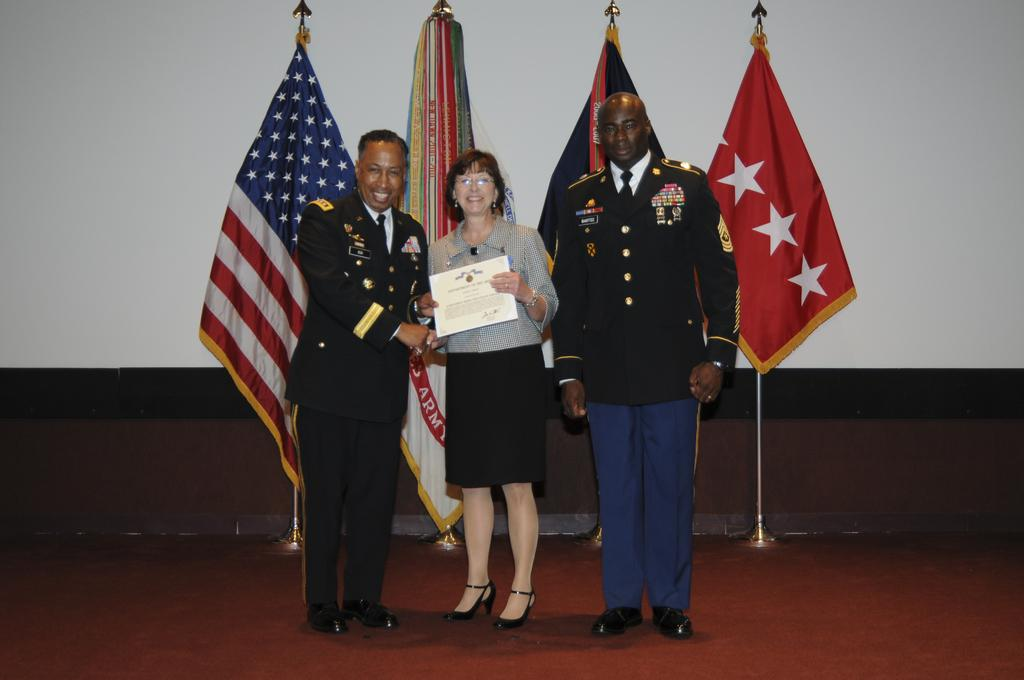How many people are present in the image? There are three people in the image: two men and a woman. What is the woman holding in the image? The woman is holding a certificate in the image. What can be seen in the background of the image? There are flags and a screen in the background of the image. What type of list can be seen on the screen in the image? There is no list visible on the screen in the image. 